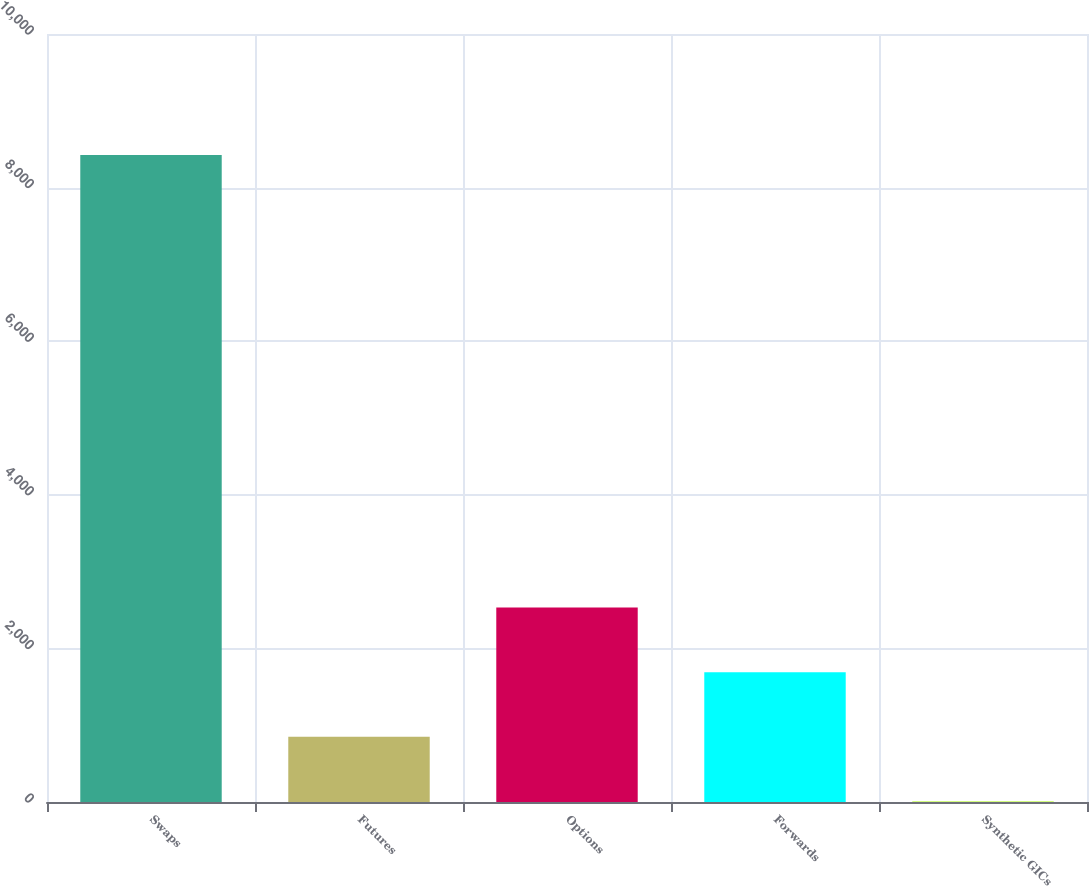<chart> <loc_0><loc_0><loc_500><loc_500><bar_chart><fcel>Swaps<fcel>Futures<fcel>Options<fcel>Forwards<fcel>Synthetic GICs<nl><fcel>8423<fcel>848.6<fcel>2531.8<fcel>1690.2<fcel>7<nl></chart> 